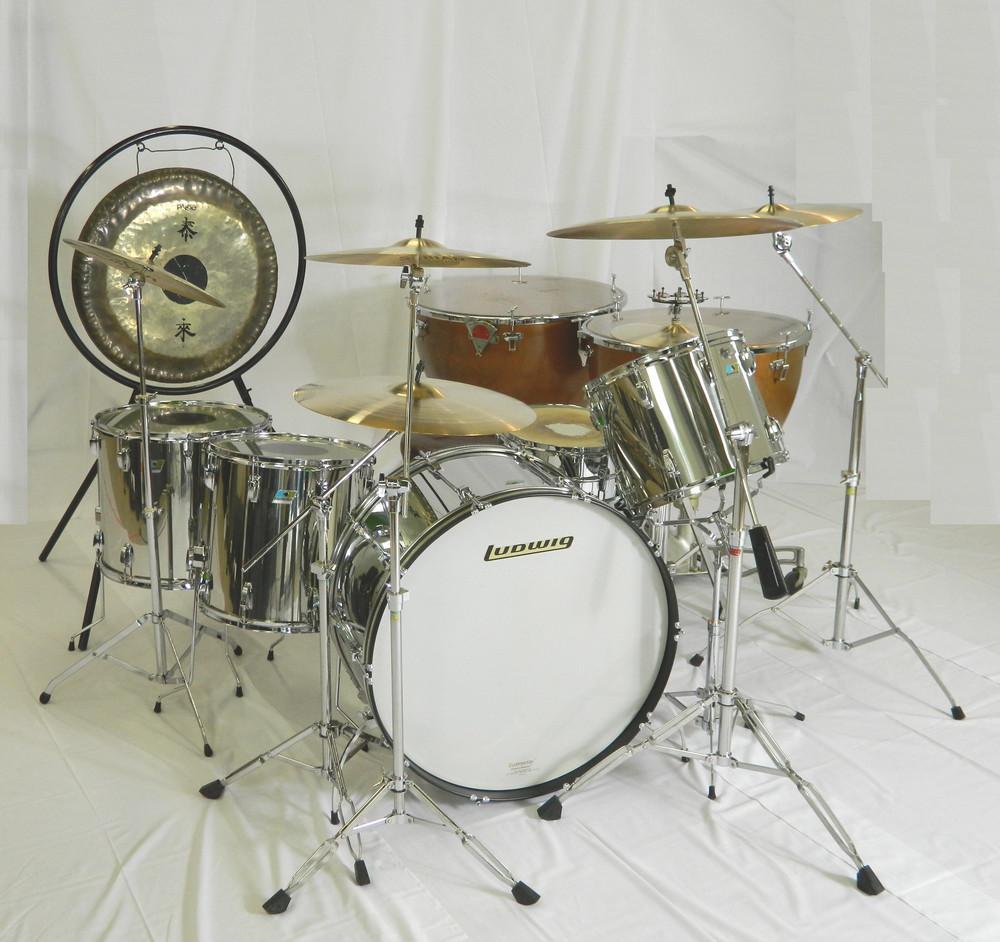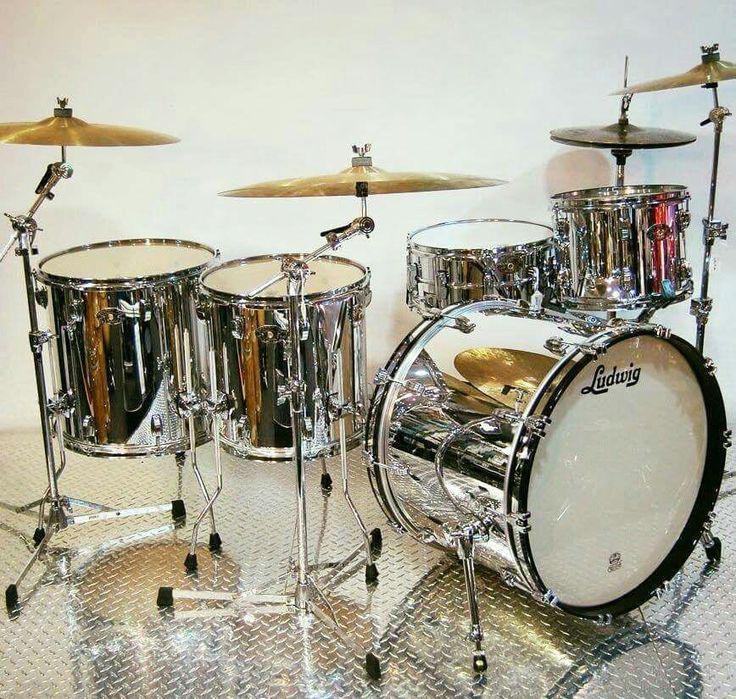The first image is the image on the left, the second image is the image on the right. Evaluate the accuracy of this statement regarding the images: "Each image shows a drum kit, but only one image features a drum kit with at least one black-faced drum that is turned on its side.". Is it true? Answer yes or no. No. The first image is the image on the left, the second image is the image on the right. Examine the images to the left and right. Is the description "At least one drum kit is silver colored." accurate? Answer yes or no. Yes. 